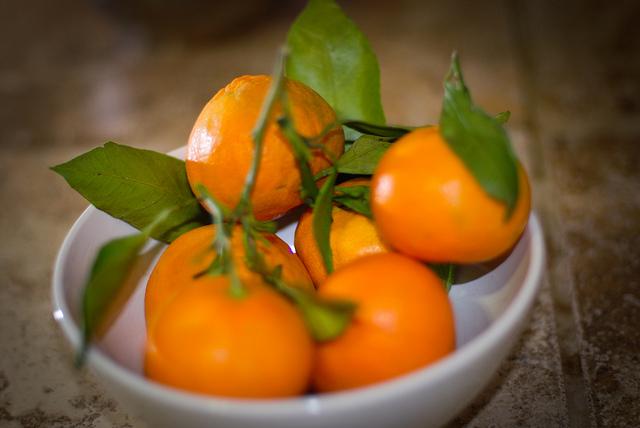Where are the stems with leaves?
Answer briefly. On oranges. Is this picture in focus?
Give a very brief answer. Yes. What color is the dish?
Give a very brief answer. White. 